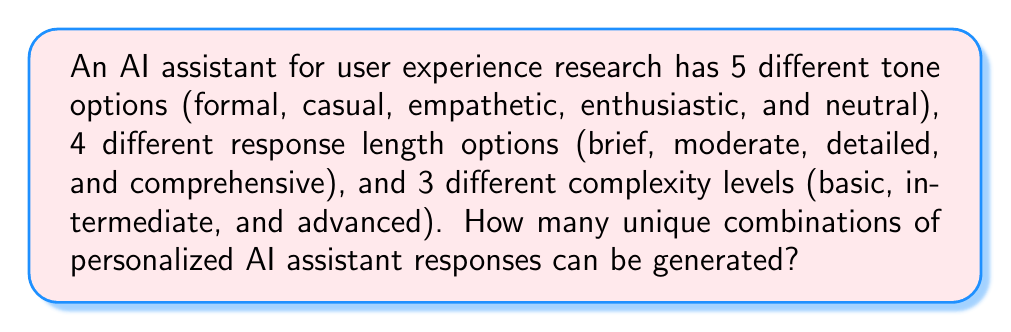Teach me how to tackle this problem. To solve this problem, we'll use the multiplication principle of counting. This principle states that if we have a series of independent choices, the total number of possible outcomes is the product of the number of options for each choice.

In this case, we have three independent choices:

1. Tone options: 5 choices
2. Response length options: 4 choices
3. Complexity levels: 3 choices

To calculate the total number of unique combinations, we multiply these numbers together:

$$ \text{Total combinations} = \text{Tone options} \times \text{Response length options} \times \text{Complexity levels} $$

$$ \text{Total combinations} = 5 \times 4 \times 3 $$

$$ \text{Total combinations} = 60 $$

This means that for each tone, we can have any of the 4 response lengths, and for each of those combinations, we can have any of the 3 complexity levels. This results in 60 unique combinations of personalized AI assistant responses.
Answer: 60 unique combinations 